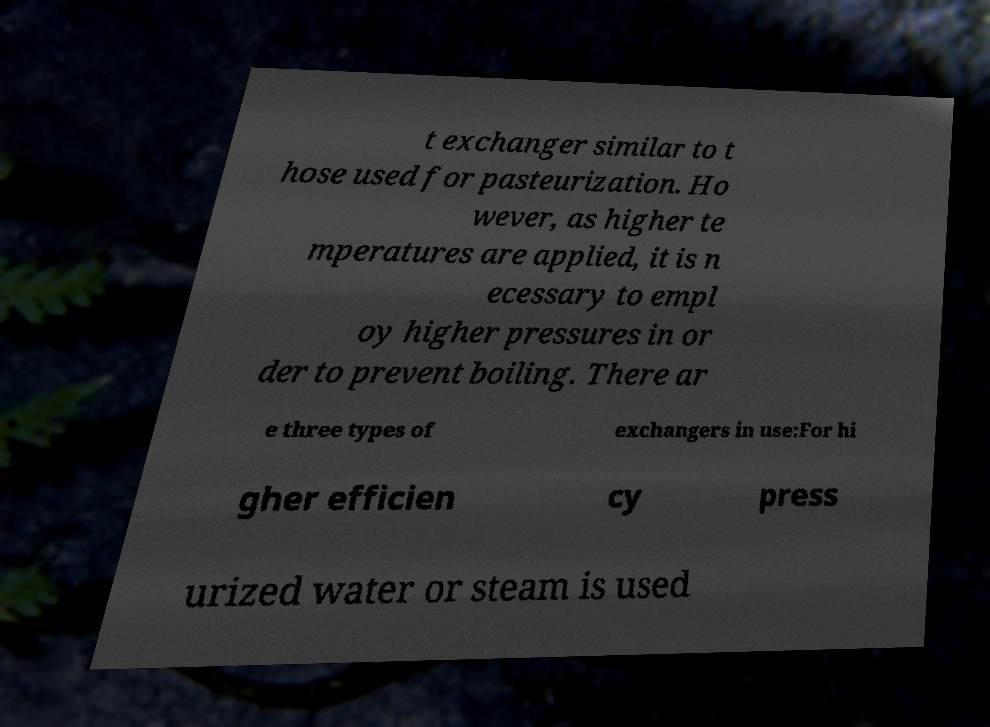Please identify and transcribe the text found in this image. t exchanger similar to t hose used for pasteurization. Ho wever, as higher te mperatures are applied, it is n ecessary to empl oy higher pressures in or der to prevent boiling. There ar e three types of exchangers in use:For hi gher efficien cy press urized water or steam is used 